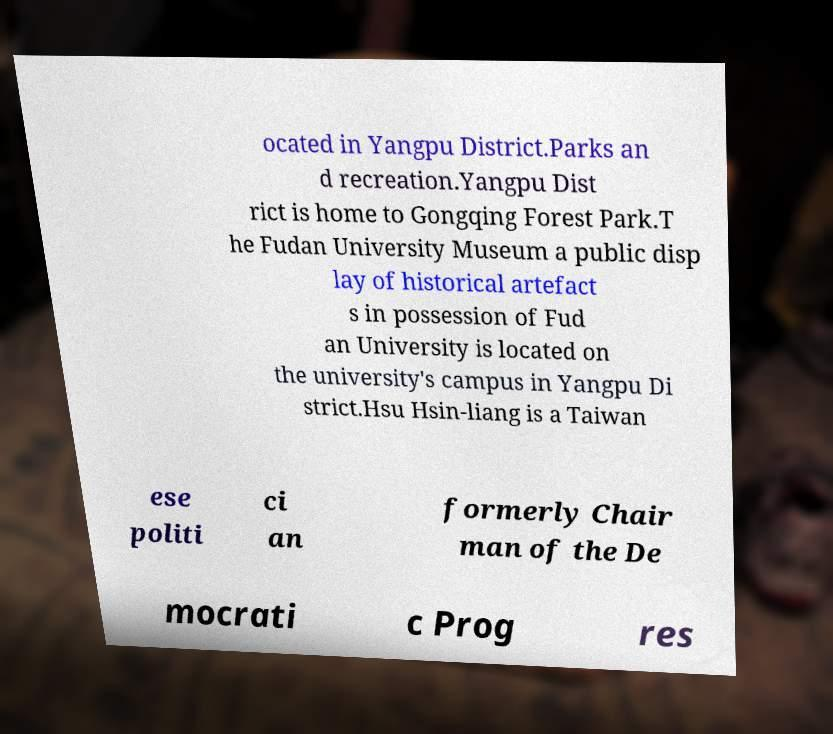Please identify and transcribe the text found in this image. ocated in Yangpu District.Parks an d recreation.Yangpu Dist rict is home to Gongqing Forest Park.T he Fudan University Museum a public disp lay of historical artefact s in possession of Fud an University is located on the university's campus in Yangpu Di strict.Hsu Hsin-liang is a Taiwan ese politi ci an formerly Chair man of the De mocrati c Prog res 